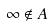Convert formula to latex. <formula><loc_0><loc_0><loc_500><loc_500>\infty \notin A</formula> 